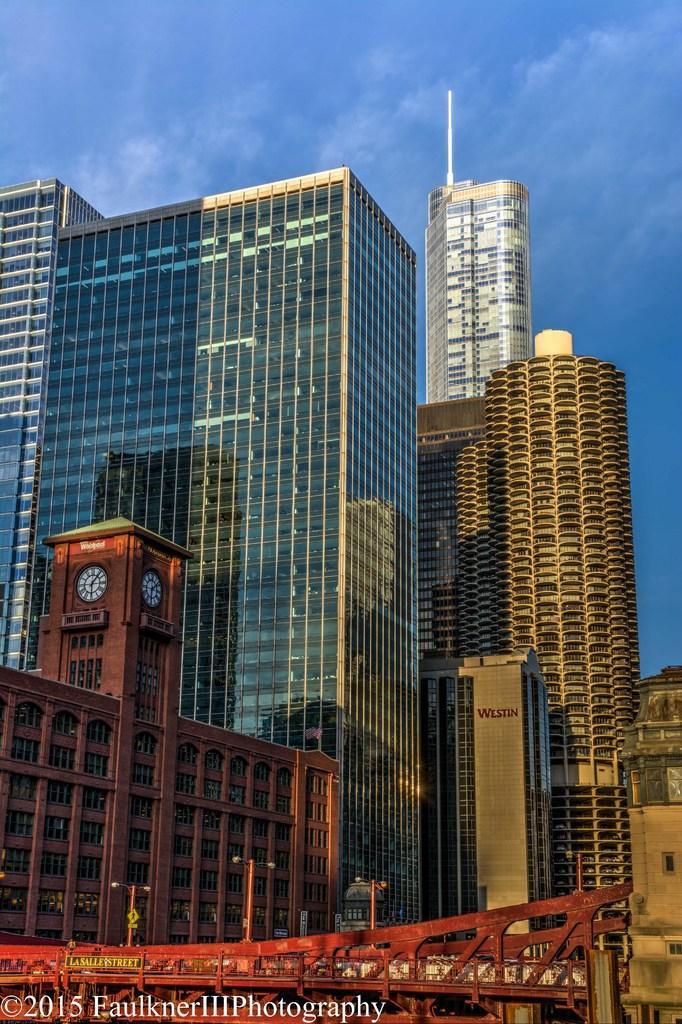How would you summarize this image in a sentence or two? In this image there are many buildings and also towers. At the top there is sky with some clouds and at the bottom there is a red color bridge. Logo is also visible. 